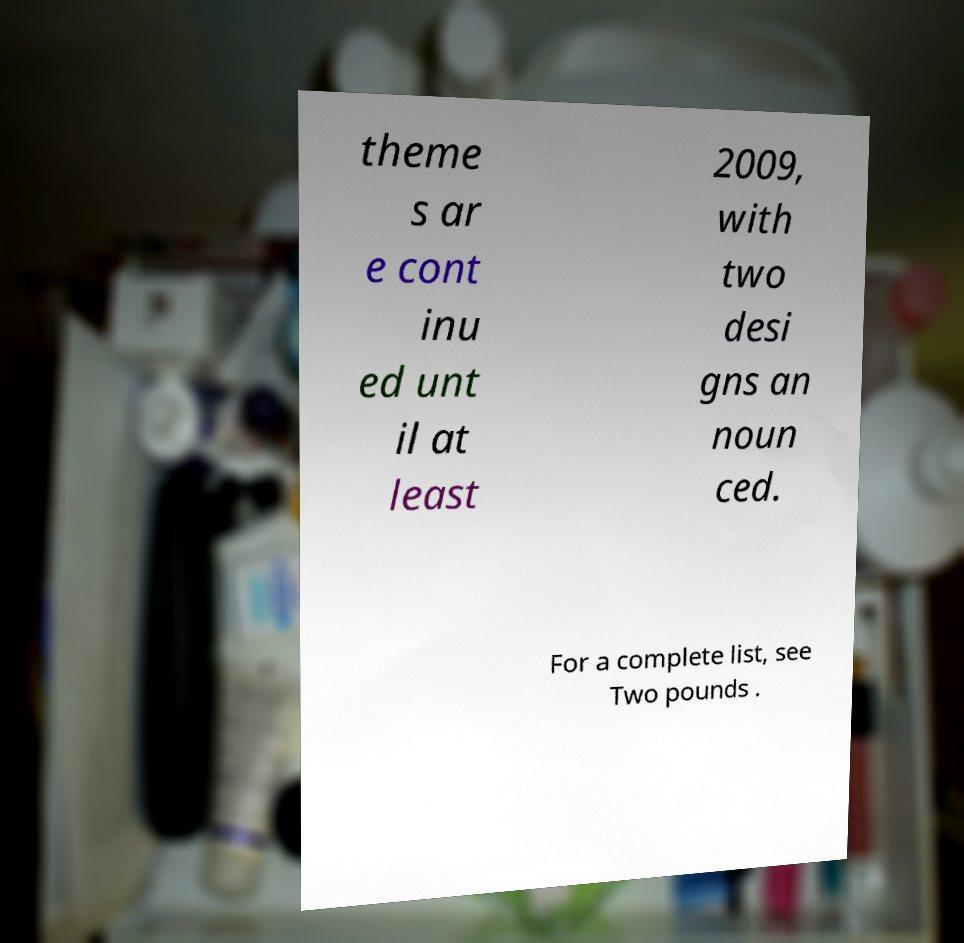Please identify and transcribe the text found in this image. theme s ar e cont inu ed unt il at least 2009, with two desi gns an noun ced. For a complete list, see Two pounds . 